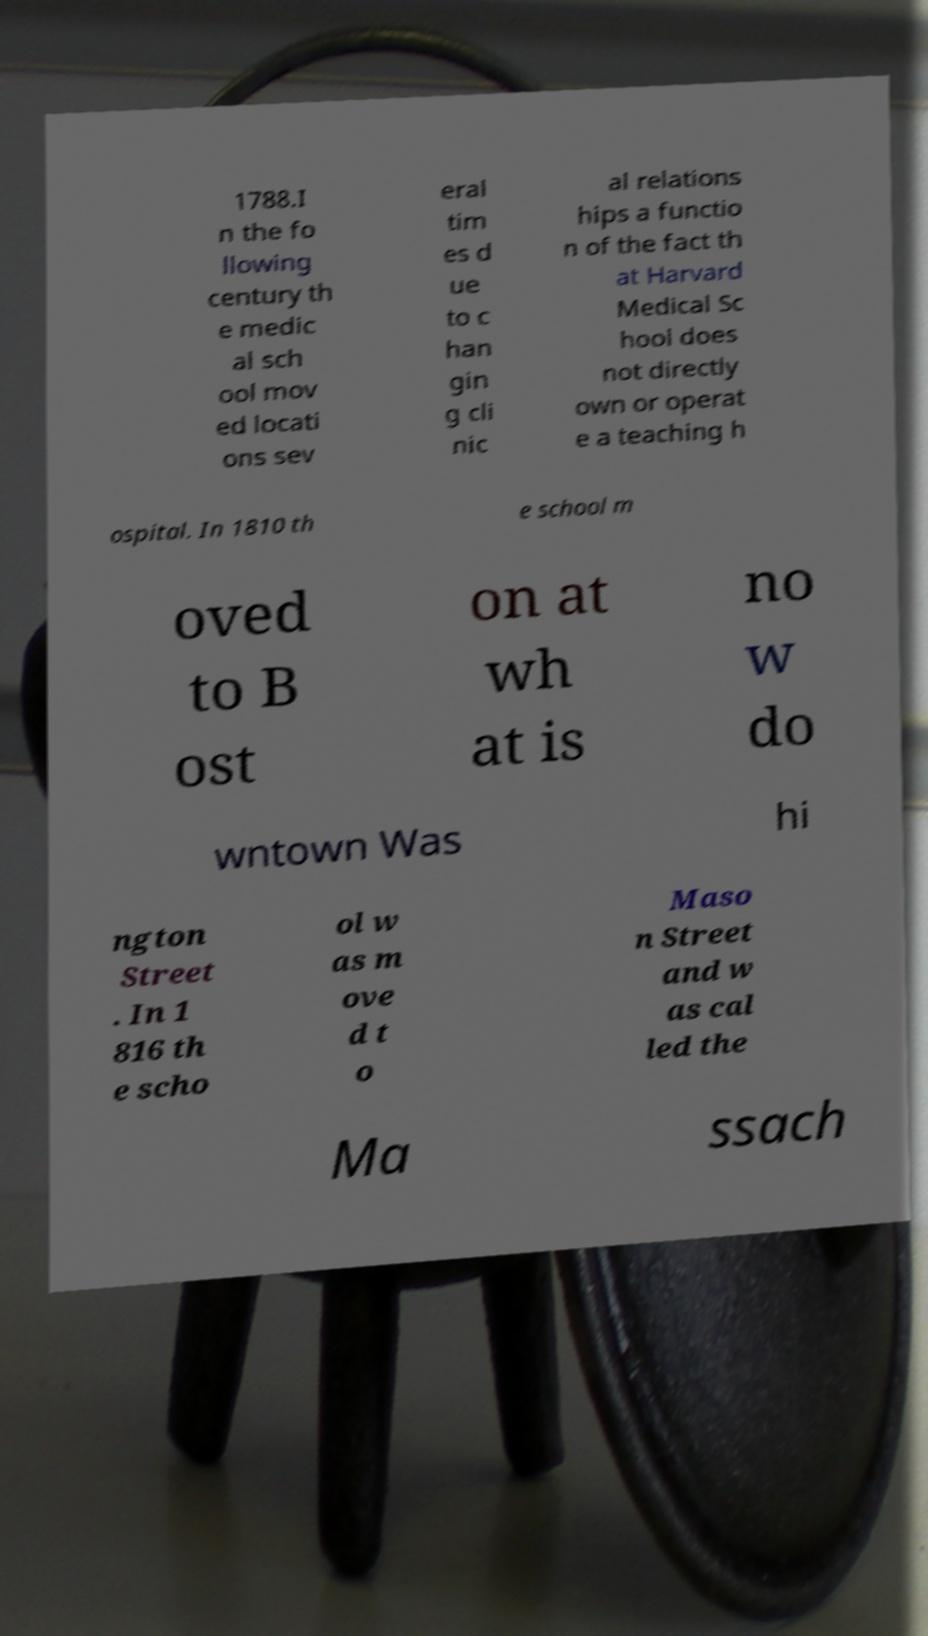Please identify and transcribe the text found in this image. 1788.I n the fo llowing century th e medic al sch ool mov ed locati ons sev eral tim es d ue to c han gin g cli nic al relations hips a functio n of the fact th at Harvard Medical Sc hool does not directly own or operat e a teaching h ospital. In 1810 th e school m oved to B ost on at wh at is no w do wntown Was hi ngton Street . In 1 816 th e scho ol w as m ove d t o Maso n Street and w as cal led the Ma ssach 